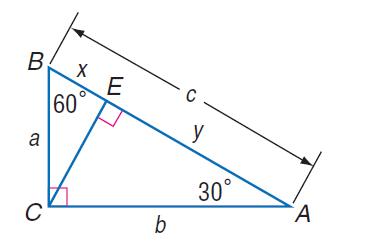Answer the mathemtical geometry problem and directly provide the correct option letter.
Question: If x = 7 \sqrt { 3 }, find C E.
Choices: A: 7 B: 14 C: 21 D: 14 \sqrt { 3 } C 